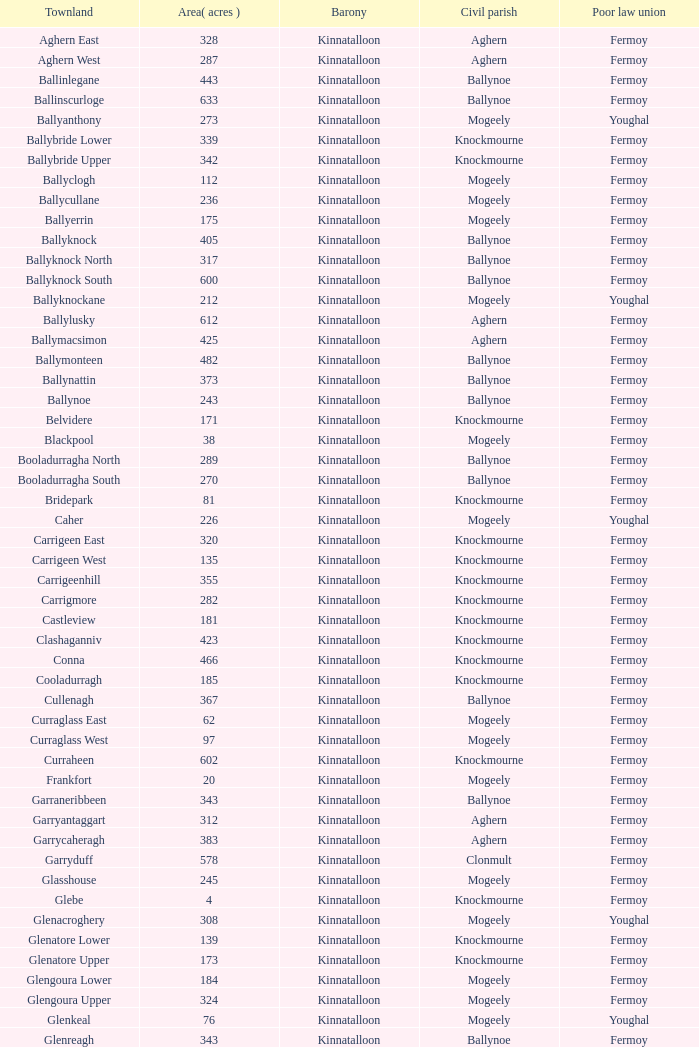Name the area for civil parish ballynoe and killasseragh 340.0. 